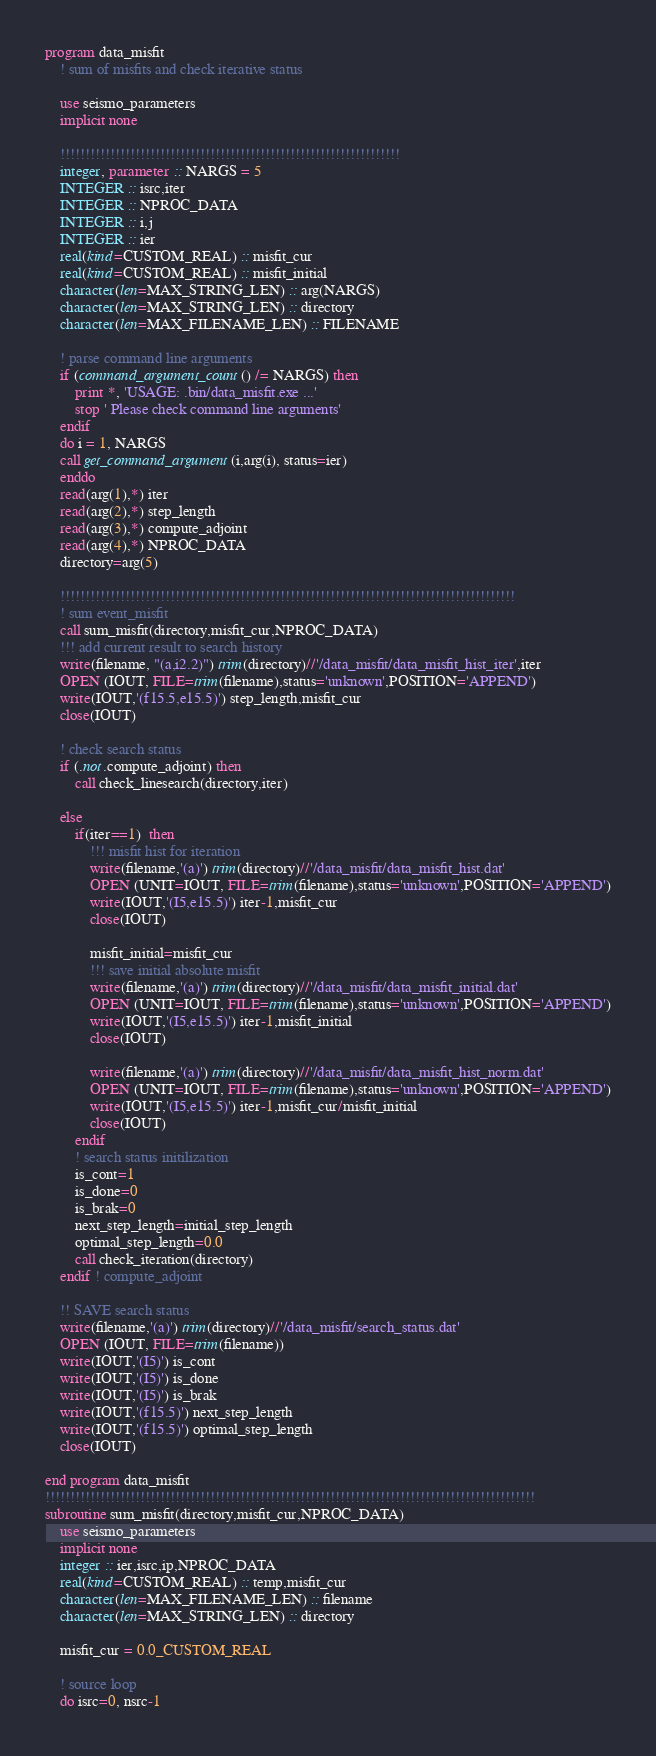<code> <loc_0><loc_0><loc_500><loc_500><_FORTRAN_>program data_misfit
    ! sum of misfits and check iterative status

    use seismo_parameters
    implicit none

    !!!!!!!!!!!!!!!!!!!!!!!!!!!!!!!!!!!!!!!!!!!!!!!!!!!!!!!!!!!!!!!!!!!!
    integer, parameter :: NARGS = 5
    INTEGER :: isrc,iter
    INTEGER :: NPROC_DATA 
    INTEGER :: i,j
    INTEGER :: ier
    real(kind=CUSTOM_REAL) :: misfit_cur
    real(kind=CUSTOM_REAL) :: misfit_initial
    character(len=MAX_STRING_LEN) :: arg(NARGS)
    character(len=MAX_STRING_LEN) :: directory
    character(len=MAX_FILENAME_LEN) :: FILENAME

    ! parse command line arguments
    if (command_argument_count() /= NARGS) then
        print *, 'USAGE: .bin/data_misfit.exe ...'
        stop ' Please check command line arguments'
    endif
    do i = 1, NARGS
    call get_command_argument(i,arg(i), status=ier)
    enddo
    read(arg(1),*) iter
    read(arg(2),*) step_length
    read(arg(3),*) compute_adjoint
    read(arg(4),*) NPROC_DATA 
    directory=arg(5)

    !!!!!!!!!!!!!!!!!!!!!!!!!!!!!!!!!!!!!!!!!!!!!!!!!!!!!!!!!!!!!!!!!!!!!!!!!!!!!!!!!!!!!!!!!!!
    ! sum event_misfit
    call sum_misfit(directory,misfit_cur,NPROC_DATA)
    !!! add current result to search history
    write(filename, "(a,i2.2)") trim(directory)//'/data_misfit/data_misfit_hist_iter',iter
    OPEN (IOUT, FILE=trim(filename),status='unknown',POSITION='APPEND')
    write(IOUT,'(f15.5,e15.5)') step_length,misfit_cur
    close(IOUT)
    
    ! check search status 
    if (.not.compute_adjoint) then 
        call check_linesearch(directory,iter) 

    else
        if(iter==1)  then
            !!! misfit hist for iteration 
            write(filename,'(a)') trim(directory)//'/data_misfit/data_misfit_hist.dat'
            OPEN (UNIT=IOUT, FILE=trim(filename),status='unknown',POSITION='APPEND')
            write(IOUT,'(I5,e15.5)') iter-1,misfit_cur
            close(IOUT)
             
            misfit_initial=misfit_cur
            !!! save initial absolute misfit
            write(filename,'(a)') trim(directory)//'/data_misfit/data_misfit_initial.dat'
            OPEN (UNIT=IOUT, FILE=trim(filename),status='unknown',POSITION='APPEND')
            write(IOUT,'(I5,e15.5)') iter-1,misfit_initial
            close(IOUT)

            write(filename,'(a)') trim(directory)//'/data_misfit/data_misfit_hist_norm.dat'
            OPEN (UNIT=IOUT, FILE=trim(filename),status='unknown',POSITION='APPEND')
            write(IOUT,'(I5,e15.5)') iter-1,misfit_cur/misfit_initial
            close(IOUT)
        endif
        ! search status initilization
        is_cont=1
        is_done=0
        is_brak=0
        next_step_length=initial_step_length
        optimal_step_length=0.0    
        call check_iteration(directory)
    endif ! compute_adjoint

    !! SAVE search status
    write(filename,'(a)') trim(directory)//'/data_misfit/search_status.dat'
    OPEN (IOUT, FILE=trim(filename))
    write(IOUT,'(I5)') is_cont
    write(IOUT,'(I5)') is_done
    write(IOUT,'(I5)') is_brak
    write(IOUT,'(f15.5)') next_step_length
    write(IOUT,'(f15.5)') optimal_step_length
    close(IOUT)

end program data_misfit
!!!!!!!!!!!!!!!!!!!!!!!!!!!!!!!!!!!!!!!!!!!!!!!!!!!!!!!!!!!!!!!!!!!!!!!!!!!!!!!!!!!!!!!!!!!!!!!!!!
subroutine sum_misfit(directory,misfit_cur,NPROC_DATA)
    use seismo_parameters
    implicit none 
    integer :: ier,isrc,ip,NPROC_DATA
    real(kind=CUSTOM_REAL) :: temp,misfit_cur
    character(len=MAX_FILENAME_LEN) :: filename
    character(len=MAX_STRING_LEN) :: directory

    misfit_cur = 0.0_CUSTOM_REAL

    ! source loop
    do isrc=0, nsrc-1</code> 